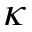Convert formula to latex. <formula><loc_0><loc_0><loc_500><loc_500>\kappa</formula> 